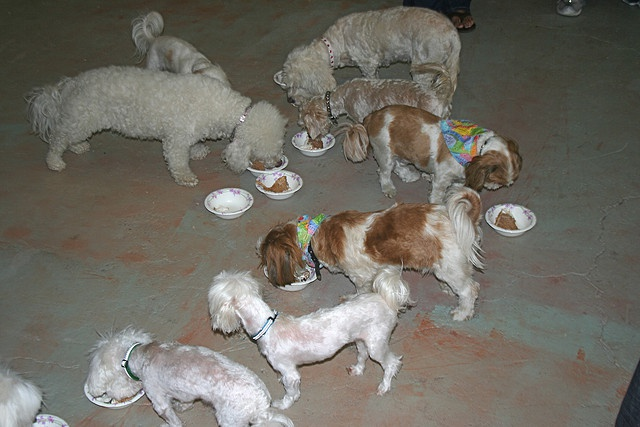Describe the objects in this image and their specific colors. I can see dog in black, darkgray, and gray tones, dog in black, darkgray, maroon, and gray tones, dog in black, lightgray, darkgray, and gray tones, dog in black, darkgray, lightgray, and gray tones, and dog in black and gray tones in this image. 